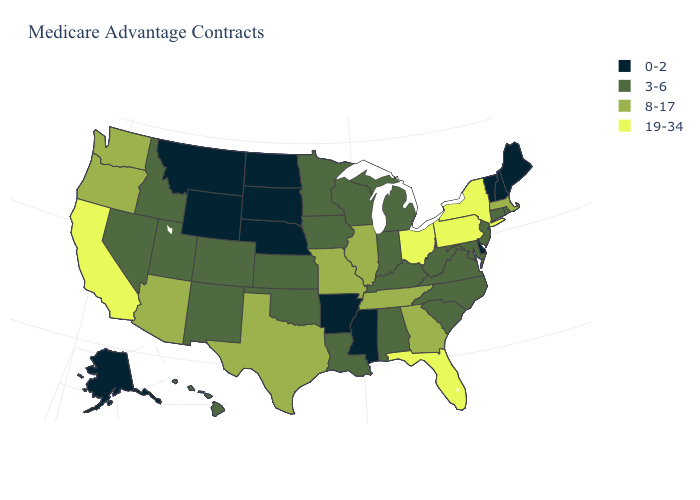What is the value of Pennsylvania?
Write a very short answer. 19-34. What is the value of Texas?
Quick response, please. 8-17. Which states have the lowest value in the South?
Write a very short answer. Arkansas, Delaware, Mississippi. What is the value of Connecticut?
Be succinct. 3-6. What is the value of Georgia?
Be succinct. 8-17. Does Pennsylvania have a higher value than Iowa?
Be succinct. Yes. Does the map have missing data?
Give a very brief answer. No. What is the highest value in the USA?
Be succinct. 19-34. Does Connecticut have a lower value than Michigan?
Give a very brief answer. No. What is the value of New Mexico?
Be succinct. 3-6. Name the states that have a value in the range 8-17?
Quick response, please. Arizona, Georgia, Illinois, Massachusetts, Missouri, Oregon, Tennessee, Texas, Washington. Name the states that have a value in the range 19-34?
Give a very brief answer. California, Florida, New York, Ohio, Pennsylvania. Name the states that have a value in the range 0-2?
Quick response, please. Alaska, Arkansas, Delaware, Maine, Mississippi, Montana, North Dakota, Nebraska, New Hampshire, South Dakota, Vermont, Wyoming. What is the value of Arkansas?
Write a very short answer. 0-2. What is the value of Colorado?
Quick response, please. 3-6. 